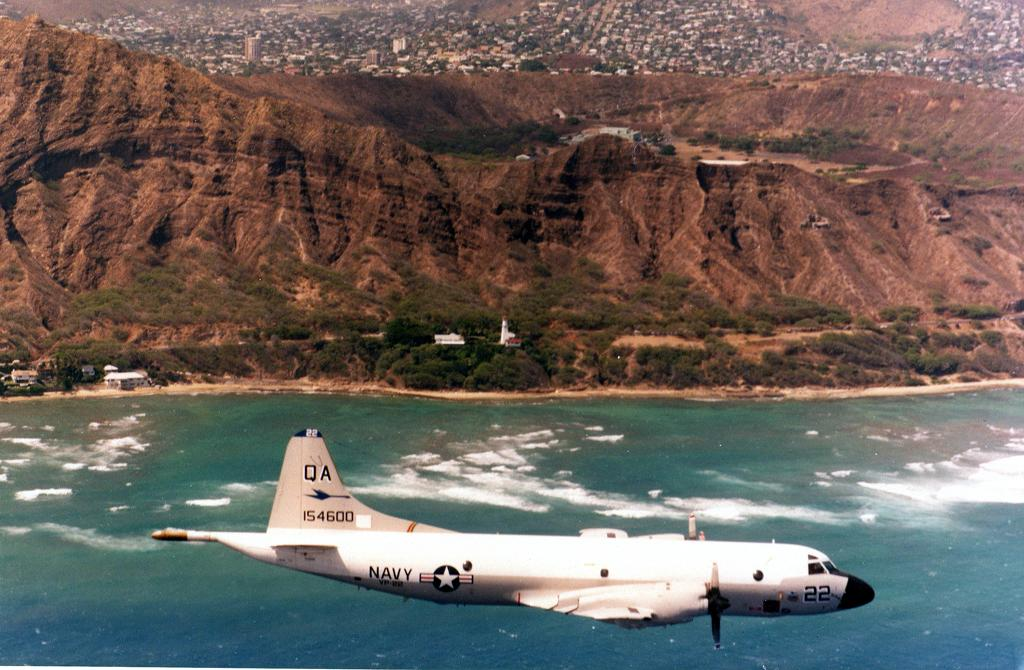<image>
Summarize the visual content of the image. a plane flying over a ocean operated by the Navy 